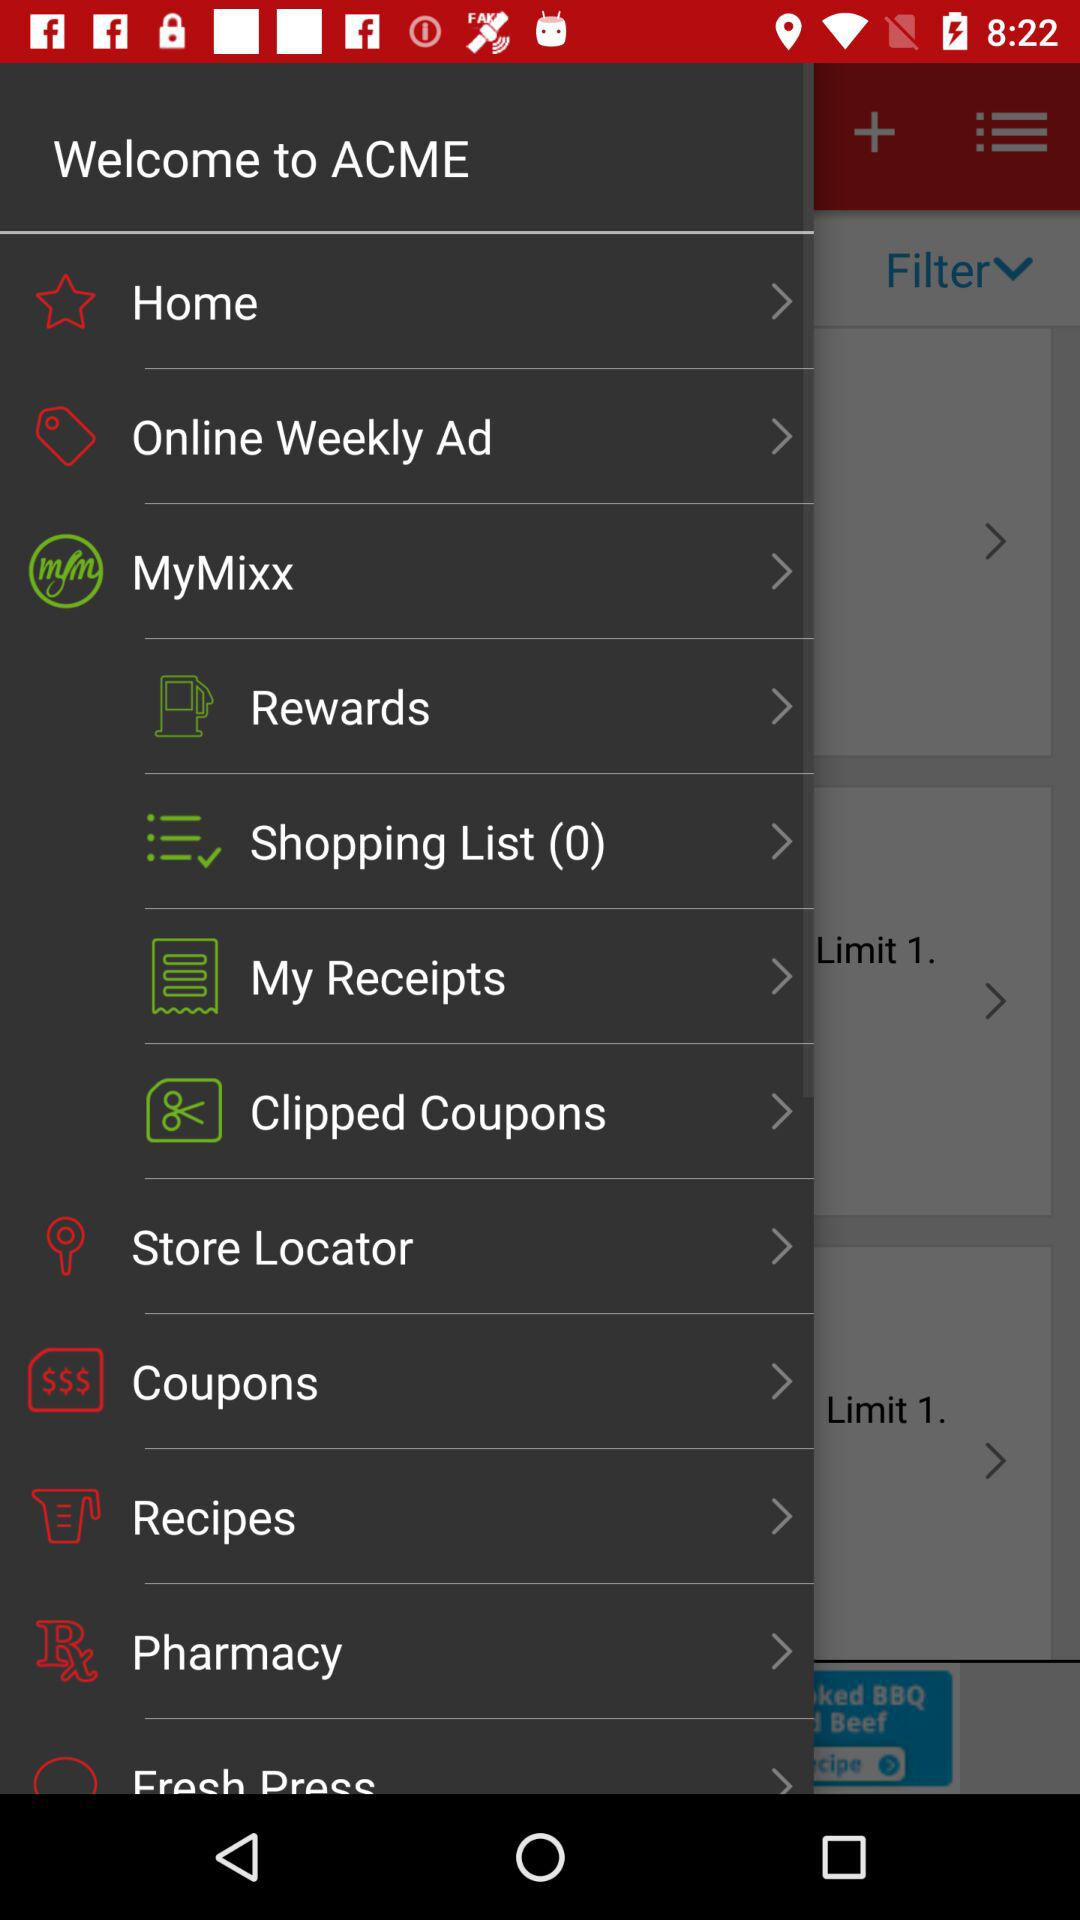How many items are there in the shopping list? There are 0 items in the shopping list. 